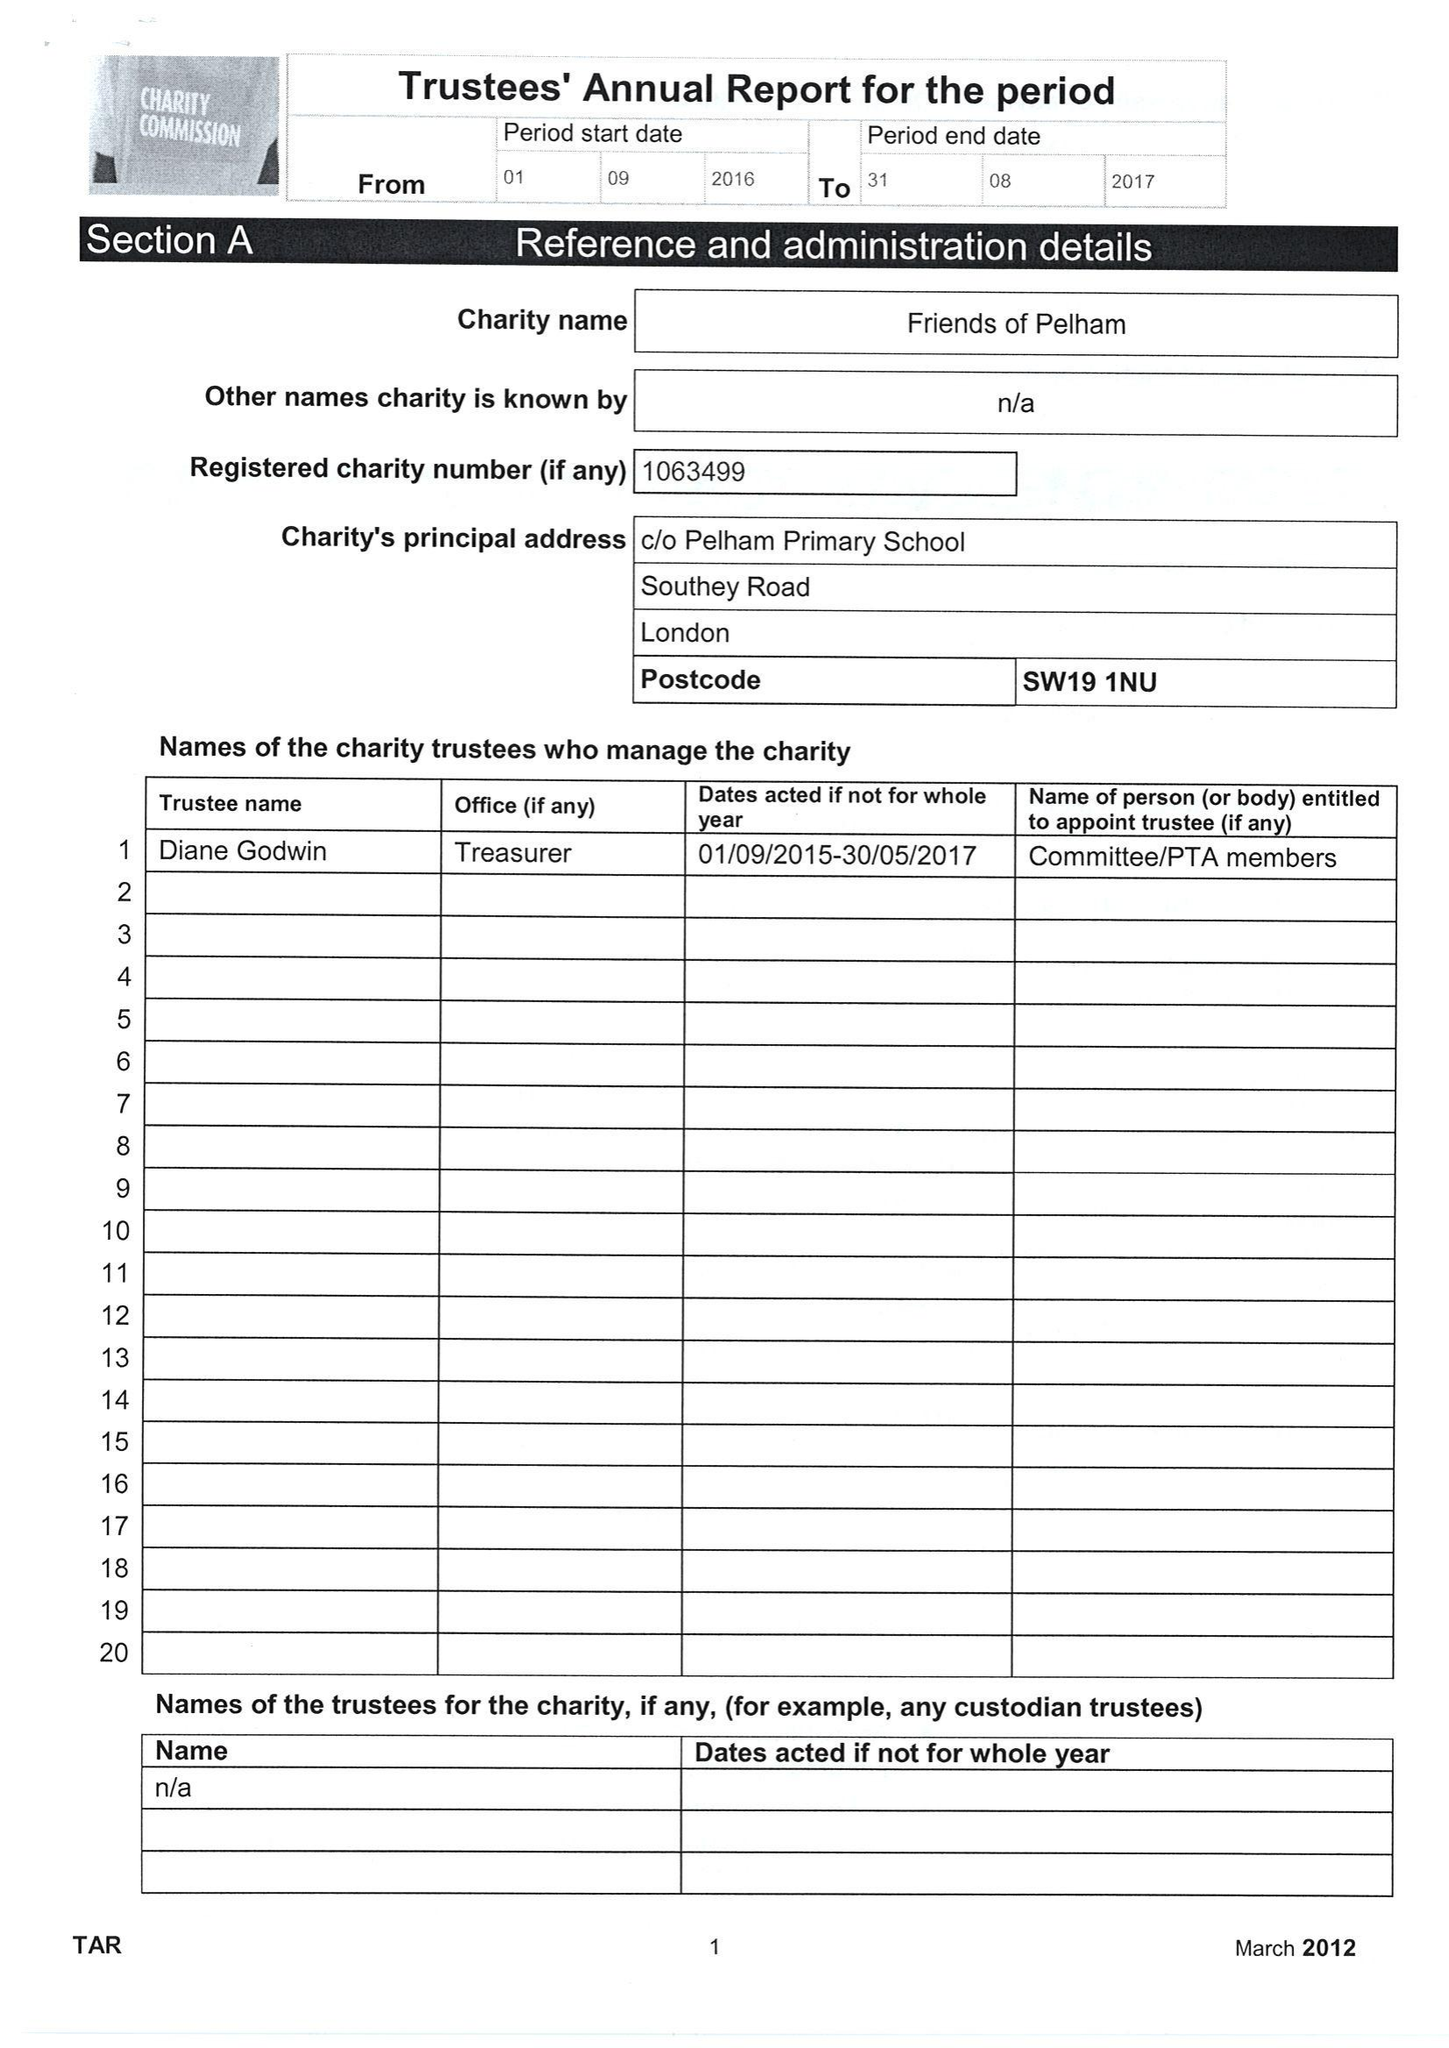What is the value for the report_date?
Answer the question using a single word or phrase. 2017-08-31 